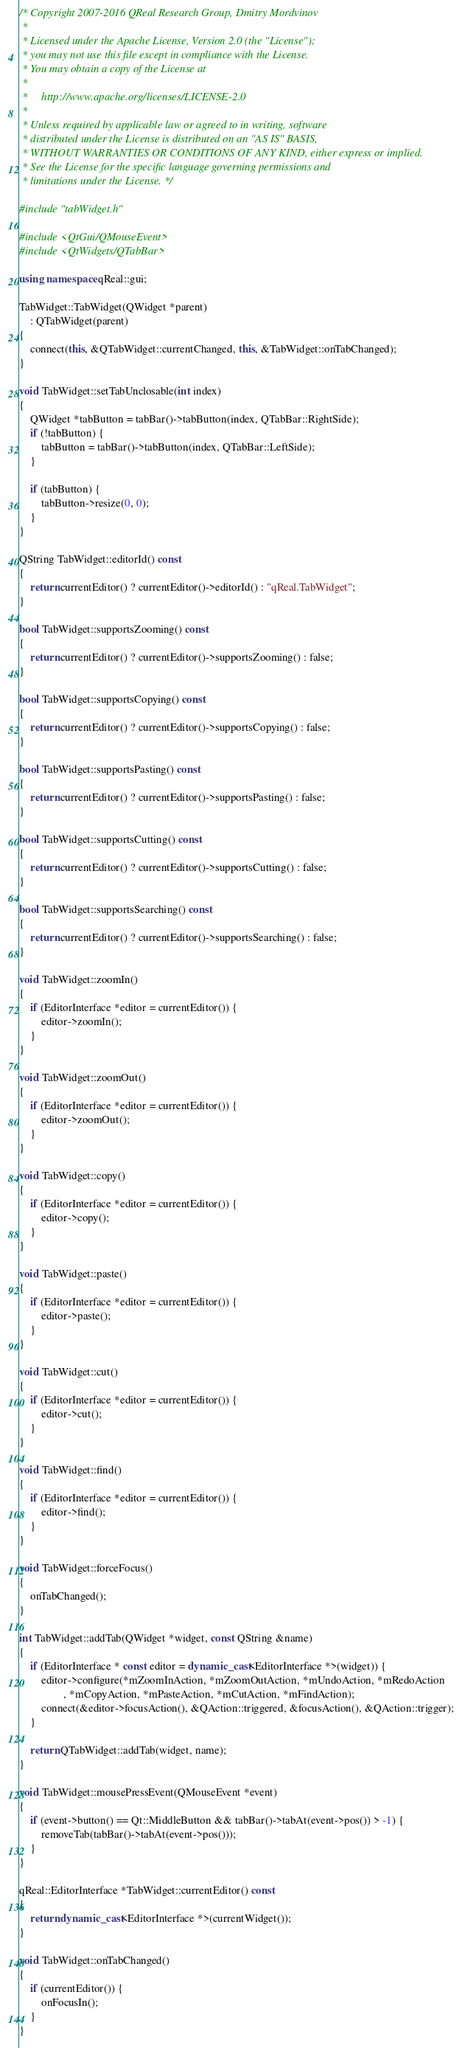Convert code to text. <code><loc_0><loc_0><loc_500><loc_500><_C++_>/* Copyright 2007-2016 QReal Research Group, Dmitry Mordvinov
 *
 * Licensed under the Apache License, Version 2.0 (the "License");
 * you may not use this file except in compliance with the License.
 * You may obtain a copy of the License at
 *
 *     http://www.apache.org/licenses/LICENSE-2.0
 *
 * Unless required by applicable law or agreed to in writing, software
 * distributed under the License is distributed on an "AS IS" BASIS,
 * WITHOUT WARRANTIES OR CONDITIONS OF ANY KIND, either express or implied.
 * See the License for the specific language governing permissions and
 * limitations under the License. */

#include "tabWidget.h"

#include <QtGui/QMouseEvent>
#include <QtWidgets/QTabBar>

using namespace qReal::gui;

TabWidget::TabWidget(QWidget *parent)
	: QTabWidget(parent)
{
	connect(this, &QTabWidget::currentChanged, this, &TabWidget::onTabChanged);
}

void TabWidget::setTabUnclosable(int index)
{
	QWidget *tabButton = tabBar()->tabButton(index, QTabBar::RightSide);
	if (!tabButton) {
		tabButton = tabBar()->tabButton(index, QTabBar::LeftSide);
	}

	if (tabButton) {
		tabButton->resize(0, 0);
	}
}

QString TabWidget::editorId() const
{
	return currentEditor() ? currentEditor()->editorId() : "qReal.TabWidget";
}

bool TabWidget::supportsZooming() const
{
	return currentEditor() ? currentEditor()->supportsZooming() : false;
}

bool TabWidget::supportsCopying() const
{
	return currentEditor() ? currentEditor()->supportsCopying() : false;
}

bool TabWidget::supportsPasting() const
{
	return currentEditor() ? currentEditor()->supportsPasting() : false;
}

bool TabWidget::supportsCutting() const
{
	return currentEditor() ? currentEditor()->supportsCutting() : false;
}

bool TabWidget::supportsSearching() const
{
	return currentEditor() ? currentEditor()->supportsSearching() : false;
}

void TabWidget::zoomIn()
{
	if (EditorInterface *editor = currentEditor()) {
		editor->zoomIn();
	}
}

void TabWidget::zoomOut()
{
	if (EditorInterface *editor = currentEditor()) {
		editor->zoomOut();
	}
}

void TabWidget::copy()
{
	if (EditorInterface *editor = currentEditor()) {
		editor->copy();
	}
}

void TabWidget::paste()
{
	if (EditorInterface *editor = currentEditor()) {
		editor->paste();
	}
}

void TabWidget::cut()
{
	if (EditorInterface *editor = currentEditor()) {
		editor->cut();
	}
}

void TabWidget::find()
{
	if (EditorInterface *editor = currentEditor()) {
		editor->find();
	}
}

void TabWidget::forceFocus()
{
	onTabChanged();
}

int TabWidget::addTab(QWidget *widget, const QString &name)
{
	if (EditorInterface * const editor = dynamic_cast<EditorInterface *>(widget)) {
		editor->configure(*mZoomInAction, *mZoomOutAction, *mUndoAction, *mRedoAction
				, *mCopyAction, *mPasteAction, *mCutAction, *mFindAction);
		connect(&editor->focusAction(), &QAction::triggered, &focusAction(), &QAction::trigger);
	}

	return QTabWidget::addTab(widget, name);
}

void TabWidget::mousePressEvent(QMouseEvent *event)
{
	if (event->button() == Qt::MiddleButton && tabBar()->tabAt(event->pos()) > -1) {
		removeTab(tabBar()->tabAt(event->pos()));
	}
}

qReal::EditorInterface *TabWidget::currentEditor() const
{
	return dynamic_cast<EditorInterface *>(currentWidget());
}

void TabWidget::onTabChanged()
{
	if (currentEditor()) {
		onFocusIn();
	}
}
</code> 